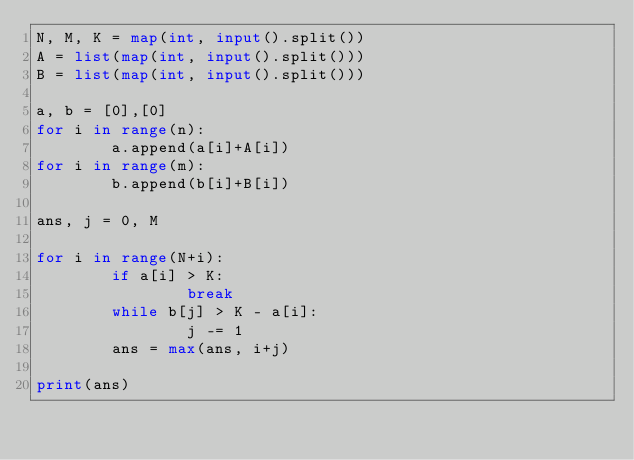Convert code to text. <code><loc_0><loc_0><loc_500><loc_500><_Python_>N, M, K = map(int, input().split())
A = list(map(int, input().split()))
B = list(map(int, input().split()))

a, b = [0],[0]
for i in range(n):
        a.append(a[i]+A[i])
for i in range(m):
        b.append(b[i]+B[i])

ans, j = 0, M

for i in range(N+i):
        if a[i] > K:
                break
        while b[j] > K - a[i]:
                j -= 1
        ans = max(ans, i+j)

print(ans)
</code> 